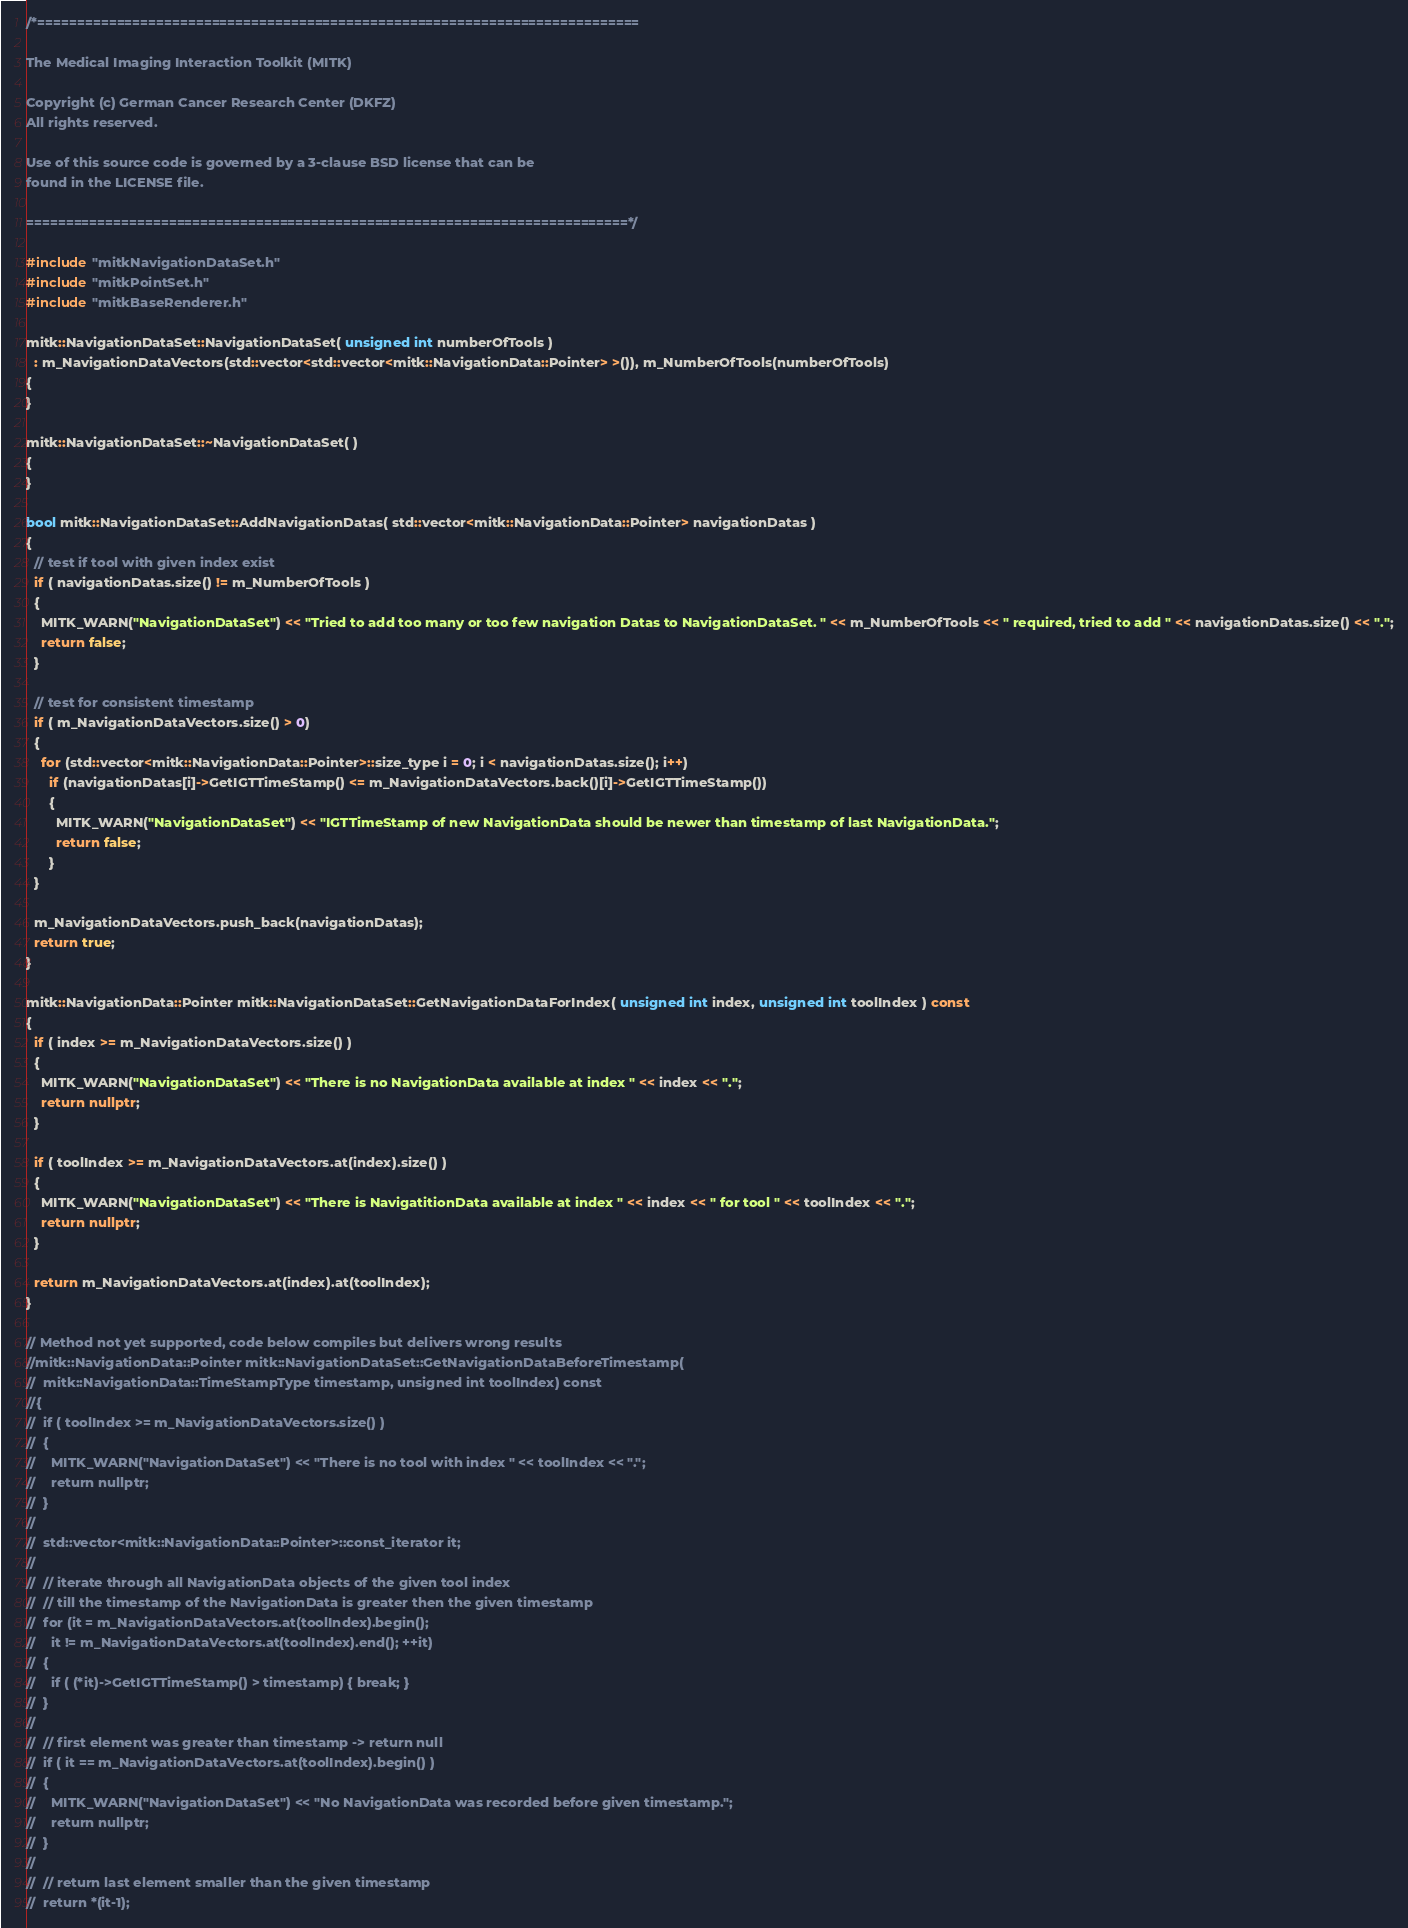<code> <loc_0><loc_0><loc_500><loc_500><_C++_>/*============================================================================

The Medical Imaging Interaction Toolkit (MITK)

Copyright (c) German Cancer Research Center (DKFZ)
All rights reserved.

Use of this source code is governed by a 3-clause BSD license that can be
found in the LICENSE file.

============================================================================*/

#include "mitkNavigationDataSet.h"
#include "mitkPointSet.h"
#include "mitkBaseRenderer.h"

mitk::NavigationDataSet::NavigationDataSet( unsigned int numberOfTools )
  : m_NavigationDataVectors(std::vector<std::vector<mitk::NavigationData::Pointer> >()), m_NumberOfTools(numberOfTools)
{
}

mitk::NavigationDataSet::~NavigationDataSet( )
{
}

bool mitk::NavigationDataSet::AddNavigationDatas( std::vector<mitk::NavigationData::Pointer> navigationDatas )
{
  // test if tool with given index exist
  if ( navigationDatas.size() != m_NumberOfTools )
  {
    MITK_WARN("NavigationDataSet") << "Tried to add too many or too few navigation Datas to NavigationDataSet. " << m_NumberOfTools << " required, tried to add " << navigationDatas.size() << ".";
    return false;
  }

  // test for consistent timestamp
  if ( m_NavigationDataVectors.size() > 0)
  {
    for (std::vector<mitk::NavigationData::Pointer>::size_type i = 0; i < navigationDatas.size(); i++)
      if (navigationDatas[i]->GetIGTTimeStamp() <= m_NavigationDataVectors.back()[i]->GetIGTTimeStamp())
      {
        MITK_WARN("NavigationDataSet") << "IGTTimeStamp of new NavigationData should be newer than timestamp of last NavigationData.";
        return false;
      }
  }

  m_NavigationDataVectors.push_back(navigationDatas);
  return true;
}

mitk::NavigationData::Pointer mitk::NavigationDataSet::GetNavigationDataForIndex( unsigned int index, unsigned int toolIndex ) const
{
  if ( index >= m_NavigationDataVectors.size() )
  {
    MITK_WARN("NavigationDataSet") << "There is no NavigationData available at index " << index << ".";
    return nullptr;
  }

  if ( toolIndex >= m_NavigationDataVectors.at(index).size() )
  {
    MITK_WARN("NavigationDataSet") << "There is NavigatitionData available at index " << index << " for tool " << toolIndex << ".";
    return nullptr;
  }

  return m_NavigationDataVectors.at(index).at(toolIndex);
}

// Method not yet supported, code below compiles but delivers wrong results
//mitk::NavigationData::Pointer mitk::NavigationDataSet::GetNavigationDataBeforeTimestamp(
//  mitk::NavigationData::TimeStampType timestamp, unsigned int toolIndex) const
//{
//  if ( toolIndex >= m_NavigationDataVectors.size() )
//  {
//    MITK_WARN("NavigationDataSet") << "There is no tool with index " << toolIndex << ".";
//    return nullptr;
//  }
//
//  std::vector<mitk::NavigationData::Pointer>::const_iterator it;
//
//  // iterate through all NavigationData objects of the given tool index
//  // till the timestamp of the NavigationData is greater then the given timestamp
//  for (it = m_NavigationDataVectors.at(toolIndex).begin();
//    it != m_NavigationDataVectors.at(toolIndex).end(); ++it)
//  {
//    if ( (*it)->GetIGTTimeStamp() > timestamp) { break; }
//  }
//
//  // first element was greater than timestamp -> return null
//  if ( it == m_NavigationDataVectors.at(toolIndex).begin() )
//  {
//    MITK_WARN("NavigationDataSet") << "No NavigationData was recorded before given timestamp.";
//    return nullptr;
//  }
//
//  // return last element smaller than the given timestamp
//  return *(it-1);</code> 